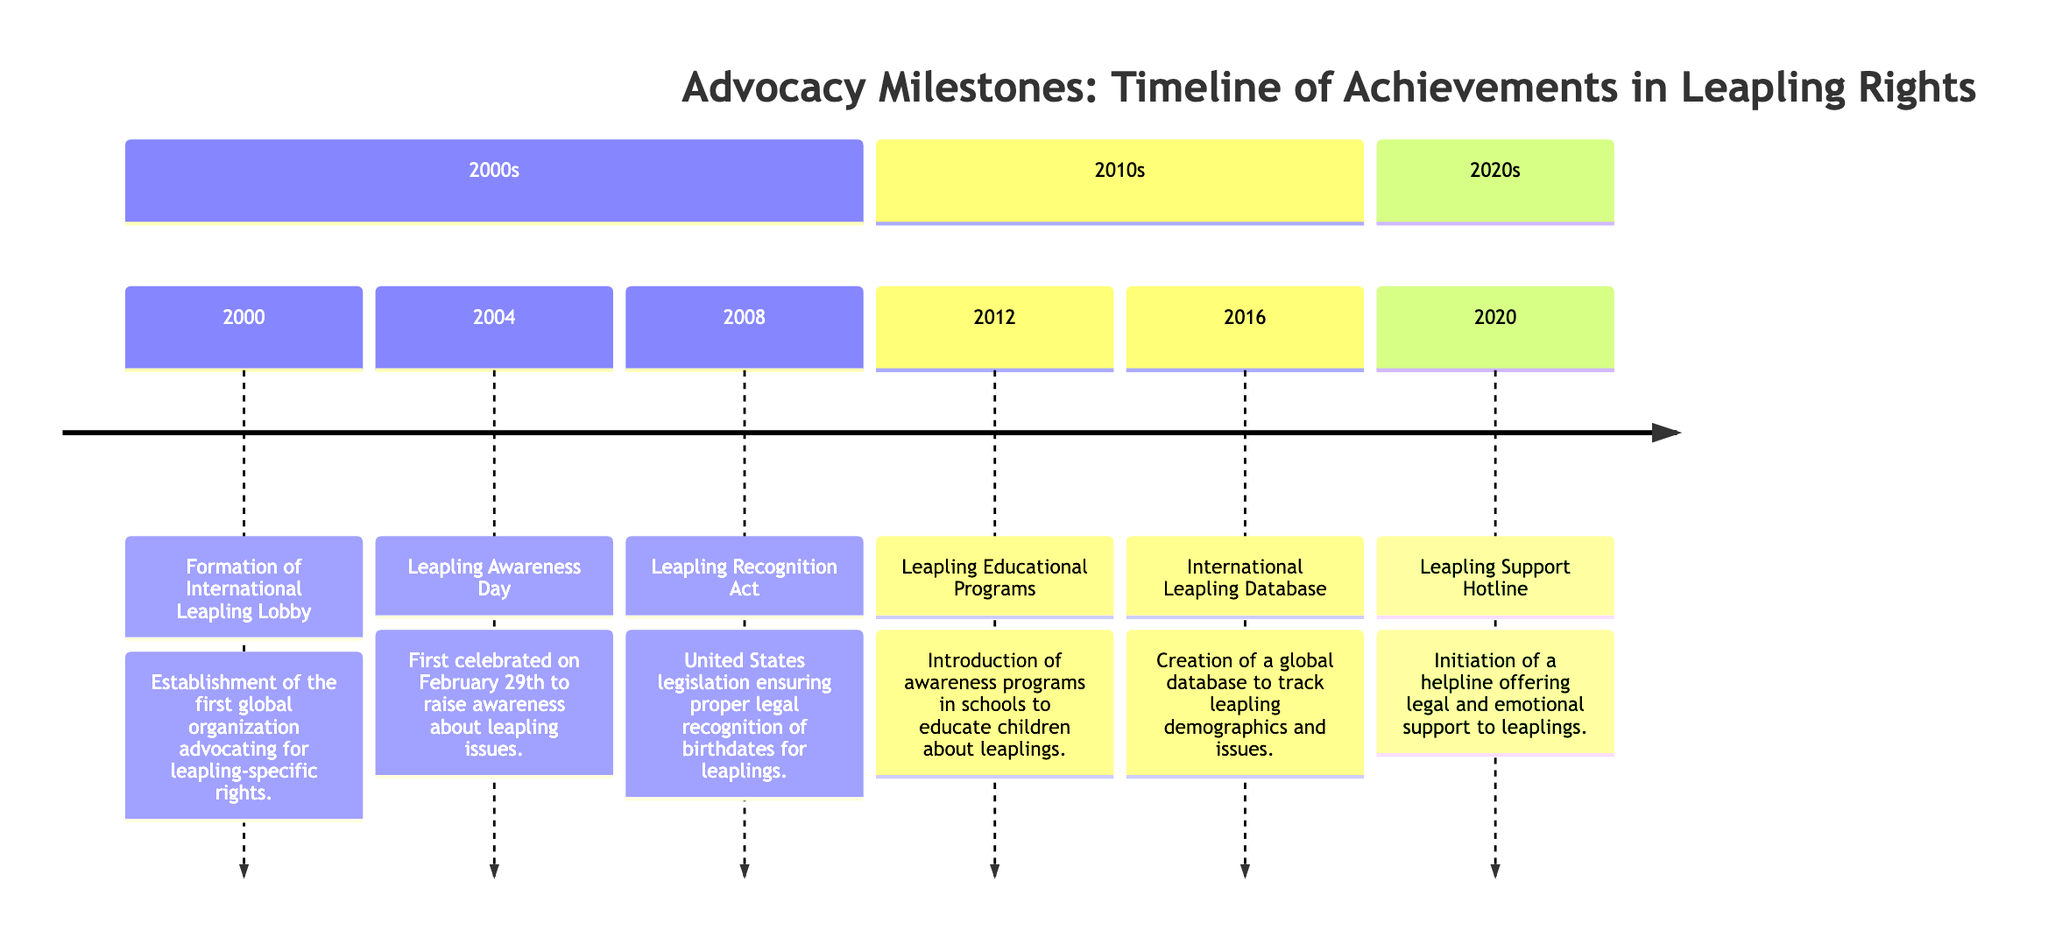What year was the Leapling Awareness Day first celebrated? The diagram indicates that Leapling Awareness Day was first celebrated in 2004. This can be found in the section detailing events from the 2000s.
Answer: 2004 What legislation was passed in 2008 for leaplings? According to the timeline, the legislation passed in 2008 is the Leapling Recognition Act, ensuring proper legal recognition of birthdates for leaplings. This information is also listed in the 2000s section.
Answer: Leapling Recognition Act How many milestones are listed in the 2010s section? The 2010s section contains two milestones: Leapling Educational Programs in 2012 and the International Leapling Database in 2016. Counting the entries in this section gives a total of two.
Answer: 2 What support was initiated in 2020? The diagram shows that a Leapling Support Hotline was initiated in 2020, offering legal and emotional support to leaplings, which is specifically mentioned in the 2020s section.
Answer: Leapling Support Hotline Which event in the 2000s focused on raising awareness? The event focusing on raising awareness in the 2000s is Leapling Awareness Day, as indicated in 2004 on the timeline, specifically aimed at increasing awareness about leapling issues.
Answer: Leapling Awareness Day What does the International Leapling Database track? The International Leapling Database, established in 2016, is described in the timeline as a means to track leapling demographics and issues. Thus, it focuses on demographic information and various challenges faced by leaplings.
Answer: Demographics and issues Which event marks the first establishment of a global organization for leapling rights? The diagram specifies that the Formation of International Leapling Lobby in 2000 is the first global organization for advocating leapling rights, making it the initial milestone in the timeline.
Answer: Formation of International Leapling Lobby In which year did the timeline show the initiation of programs in educational institutions? The timeline shows that the initiation of Leapling Educational Programs in schools occurred in 2012, detailed clearly in the 2010s section.
Answer: 2012 